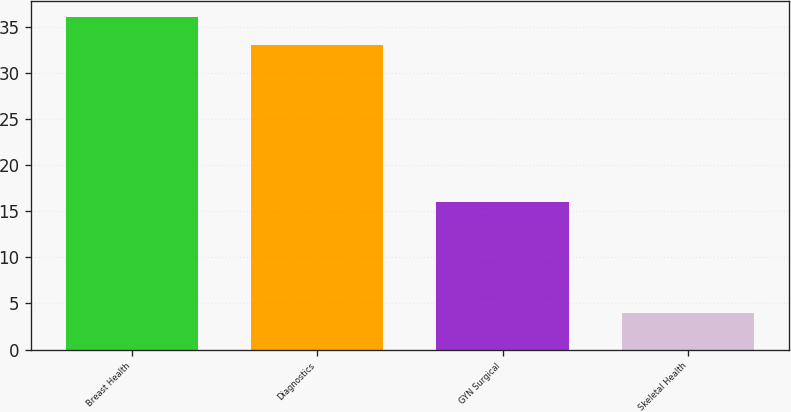<chart> <loc_0><loc_0><loc_500><loc_500><bar_chart><fcel>Breast Health<fcel>Diagnostics<fcel>GYN Surgical<fcel>Skeletal Health<nl><fcel>36<fcel>33<fcel>16<fcel>4<nl></chart> 